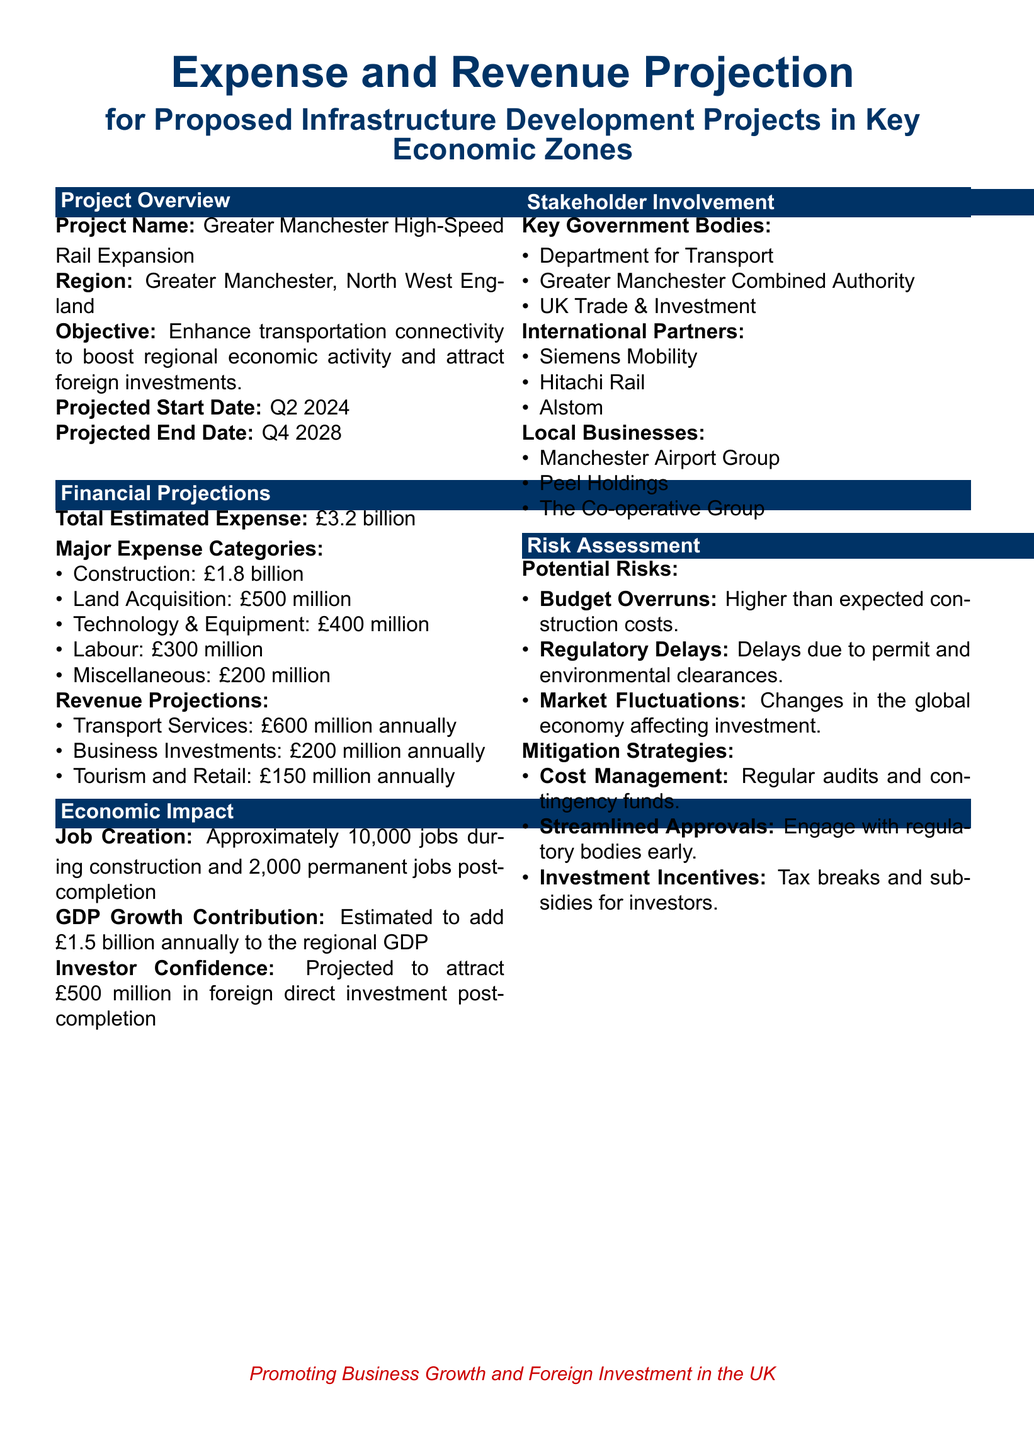what is the total estimated expense? The total estimated expense for the project is stated in the financial projections section of the document.
Answer: £3.2 billion what is the projected start date of the project? The projected start date can be found in the project overview section of the document.
Answer: Q2 2024 how many permanent jobs will be created post-completion? The number of permanent jobs created post-completion is mentioned in the economic impact section of the document.
Answer: 2,000 what is the projected GDP growth contribution? The projected GDP growth contribution can be found in the economic impact section, detailing the specific contribution value.
Answer: £1.5 billion annually which government body is involved in the project? The key government bodies involved are listed in the stakeholder involvement section of the document.
Answer: Department for Transport what are the major expense categories? The major expense categories are detailed under the financial projections section, showing the breakdown of expenses.
Answer: Construction, Land Acquisition, Technology & Equipment, Labour, Miscellaneous what is the estimated annual revenue from transport services? The estimated annual revenue from transport services is indicated under the revenue projections in the financial projections section.
Answer: £600 million what is one of the potential risks mentioned? The document lists potential risks in the risk assessment section.
Answer: Budget Overruns what investment is projected to attract post-completion? The amount projected to attract post-completion is laid out in the economic impact section.
Answer: £500 million 